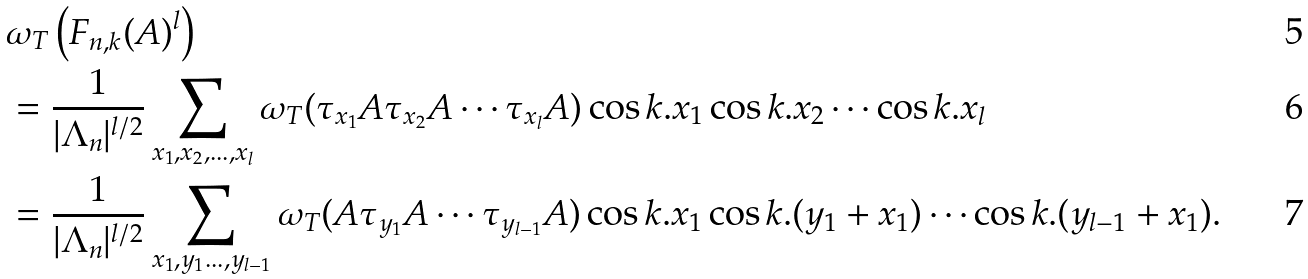Convert formula to latex. <formula><loc_0><loc_0><loc_500><loc_500>& \omega _ { T } \left ( F _ { n , k } ( A ) ^ { l } \right ) \\ & = \frac { 1 } { | \Lambda _ { n } | ^ { l / 2 } } \sum _ { x _ { 1 } , x _ { 2 } , \dots , x _ { l } } \omega _ { T } ( \tau _ { x _ { 1 } } A \tau _ { x _ { 2 } } A \cdots \tau _ { x _ { l } } A ) \cos k . x _ { 1 } \cos k . x _ { 2 } \cdots \cos k . x _ { l } \\ & = \frac { 1 } { | \Lambda _ { n } | ^ { l / 2 } } \sum _ { x _ { 1 } , y _ { 1 } \dots , y _ { l - 1 } } \omega _ { T } ( A \tau _ { y _ { 1 } } A \cdots \tau _ { y _ { l - 1 } } A ) \cos k . x _ { 1 } \cos k . ( y _ { 1 } + x _ { 1 } ) \cdots \cos k . ( y _ { l - 1 } + x _ { 1 } ) .</formula> 